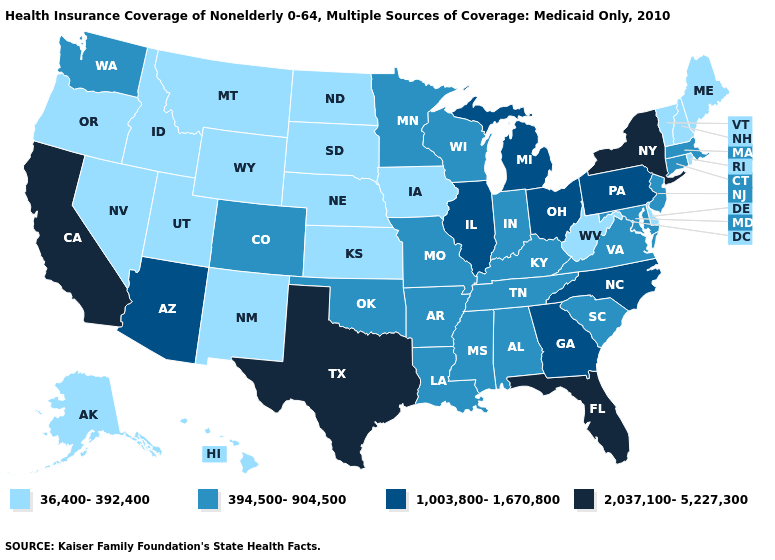What is the value of Minnesota?
Answer briefly. 394,500-904,500. Name the states that have a value in the range 1,003,800-1,670,800?
Give a very brief answer. Arizona, Georgia, Illinois, Michigan, North Carolina, Ohio, Pennsylvania. Which states have the lowest value in the MidWest?
Keep it brief. Iowa, Kansas, Nebraska, North Dakota, South Dakota. Name the states that have a value in the range 1,003,800-1,670,800?
Keep it brief. Arizona, Georgia, Illinois, Michigan, North Carolina, Ohio, Pennsylvania. Which states have the highest value in the USA?
Keep it brief. California, Florida, New York, Texas. Name the states that have a value in the range 394,500-904,500?
Give a very brief answer. Alabama, Arkansas, Colorado, Connecticut, Indiana, Kentucky, Louisiana, Maryland, Massachusetts, Minnesota, Mississippi, Missouri, New Jersey, Oklahoma, South Carolina, Tennessee, Virginia, Washington, Wisconsin. What is the highest value in states that border Connecticut?
Concise answer only. 2,037,100-5,227,300. Does the first symbol in the legend represent the smallest category?
Write a very short answer. Yes. Does Hawaii have the same value as Kansas?
Concise answer only. Yes. Which states have the lowest value in the USA?
Keep it brief. Alaska, Delaware, Hawaii, Idaho, Iowa, Kansas, Maine, Montana, Nebraska, Nevada, New Hampshire, New Mexico, North Dakota, Oregon, Rhode Island, South Dakota, Utah, Vermont, West Virginia, Wyoming. Does the first symbol in the legend represent the smallest category?
Keep it brief. Yes. Among the states that border Arizona , which have the highest value?
Write a very short answer. California. Name the states that have a value in the range 36,400-392,400?
Be succinct. Alaska, Delaware, Hawaii, Idaho, Iowa, Kansas, Maine, Montana, Nebraska, Nevada, New Hampshire, New Mexico, North Dakota, Oregon, Rhode Island, South Dakota, Utah, Vermont, West Virginia, Wyoming. What is the value of Missouri?
Write a very short answer. 394,500-904,500. 